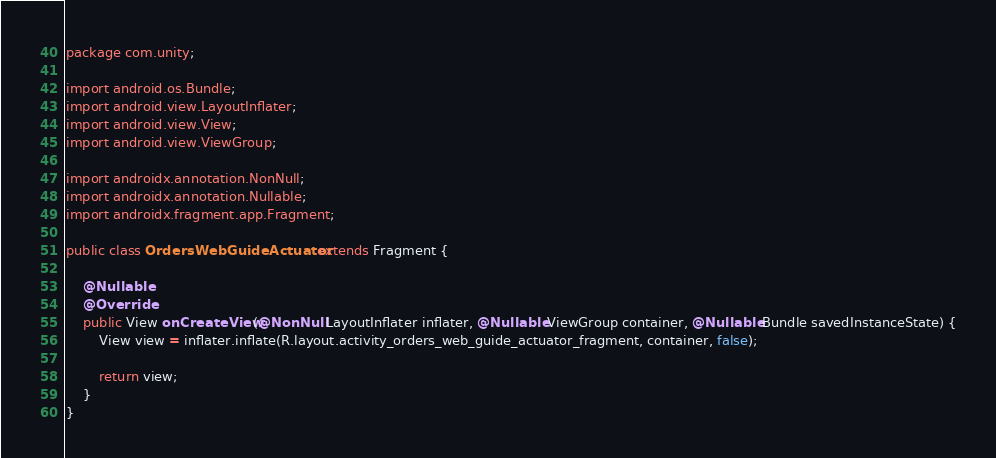<code> <loc_0><loc_0><loc_500><loc_500><_Java_>package com.unity;

import android.os.Bundle;
import android.view.LayoutInflater;
import android.view.View;
import android.view.ViewGroup;

import androidx.annotation.NonNull;
import androidx.annotation.Nullable;
import androidx.fragment.app.Fragment;

public class OrdersWebGuideActuator extends Fragment {

    @Nullable
    @Override
    public View onCreateView(@NonNull LayoutInflater inflater, @Nullable ViewGroup container, @Nullable Bundle savedInstanceState) {
        View view = inflater.inflate(R.layout.activity_orders_web_guide_actuator_fragment, container, false);

        return view;
    }
}
</code> 